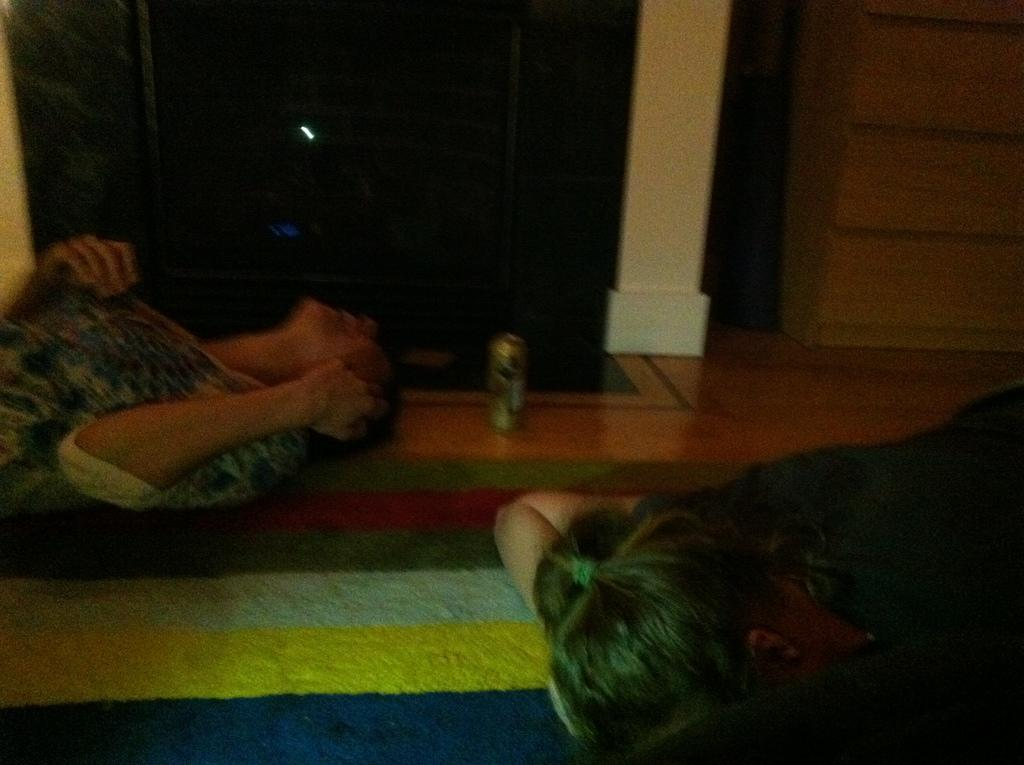How many people are in the image? There are two persons in the image. What are the persons doing in the image? The persons are laying on the floor. Where is the floor located? The floor is in a room. What is on the floor in the image? There is a floor mat and an object on the floor. What type of curtain is hanging near the persons in the image? There is no curtain present in the image. Can you tell me how many fingers the persons are holding up in the image? The image does not show the persons' hands or fingers, so it cannot be determined from the image. 